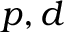Convert formula to latex. <formula><loc_0><loc_0><loc_500><loc_500>p , d</formula> 